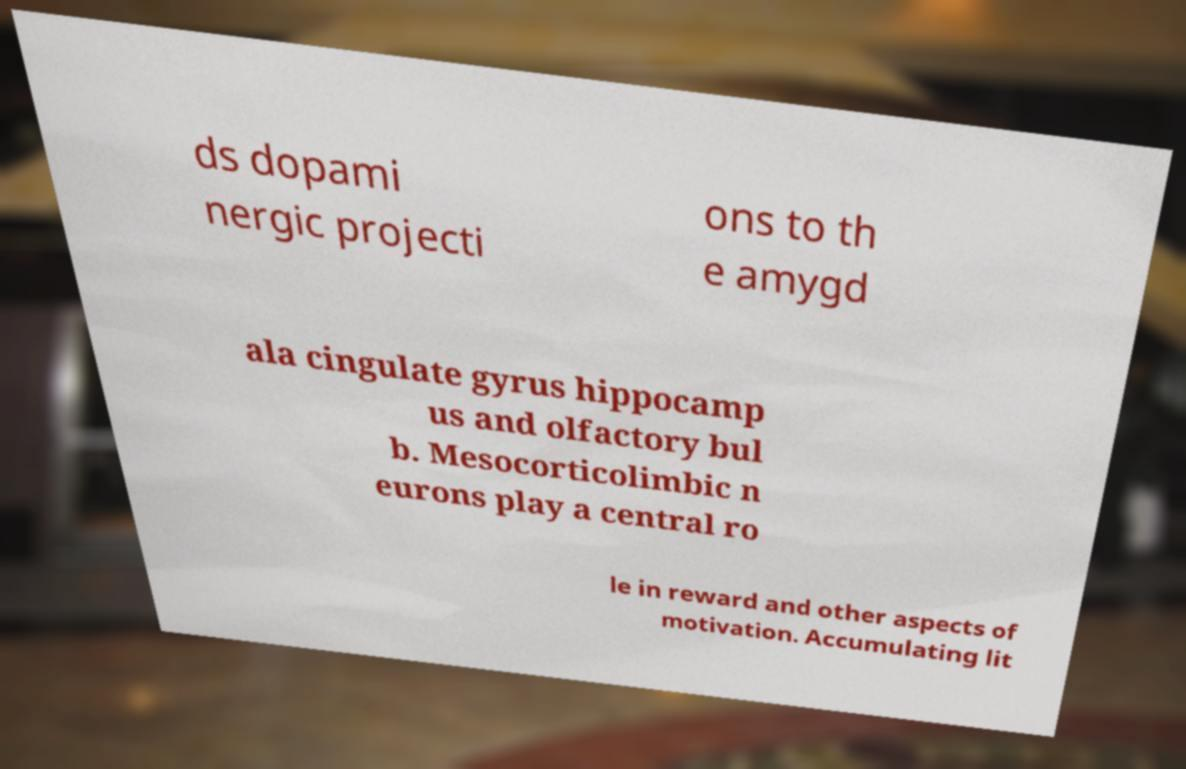For documentation purposes, I need the text within this image transcribed. Could you provide that? ds dopami nergic projecti ons to th e amygd ala cingulate gyrus hippocamp us and olfactory bul b. Mesocorticolimbic n eurons play a central ro le in reward and other aspects of motivation. Accumulating lit 